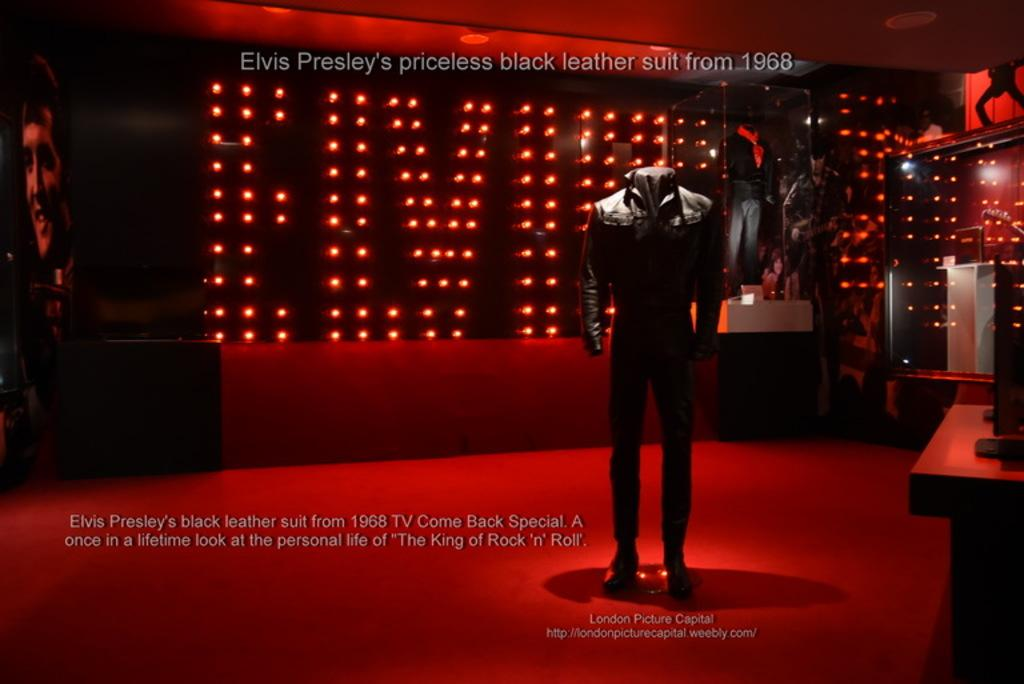What is the main subject in the image? There is a mannequin in the image. What can be seen in the background of the image? There is a screen, a mirror, and lights visible in the background of the image. Is there any text present in the image? Yes, there is text visible in the image. How much dirt is visible on the mannequin in the image? There is no dirt visible on the mannequin in the image. What type of calendar is hanging on the wall in the image? There is no calendar present in the image. 